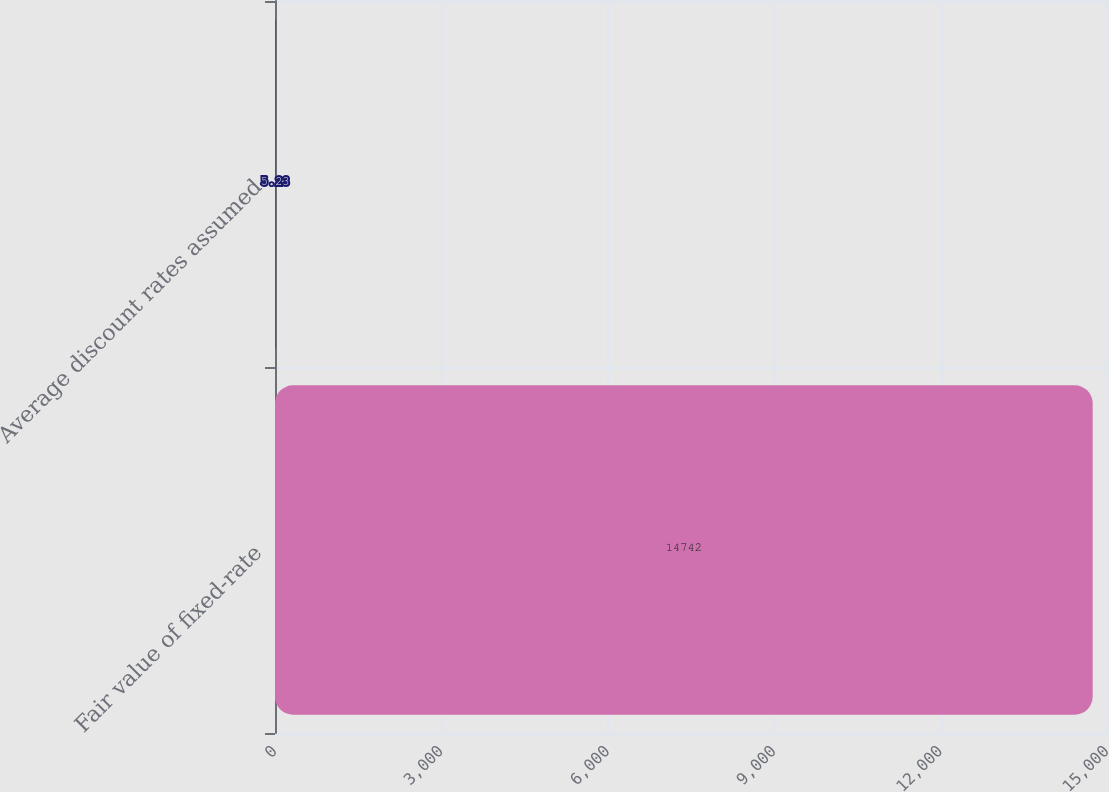<chart> <loc_0><loc_0><loc_500><loc_500><bar_chart><fcel>Fair value of fixed-rate<fcel>Average discount rates assumed<nl><fcel>14742<fcel>5.23<nl></chart> 